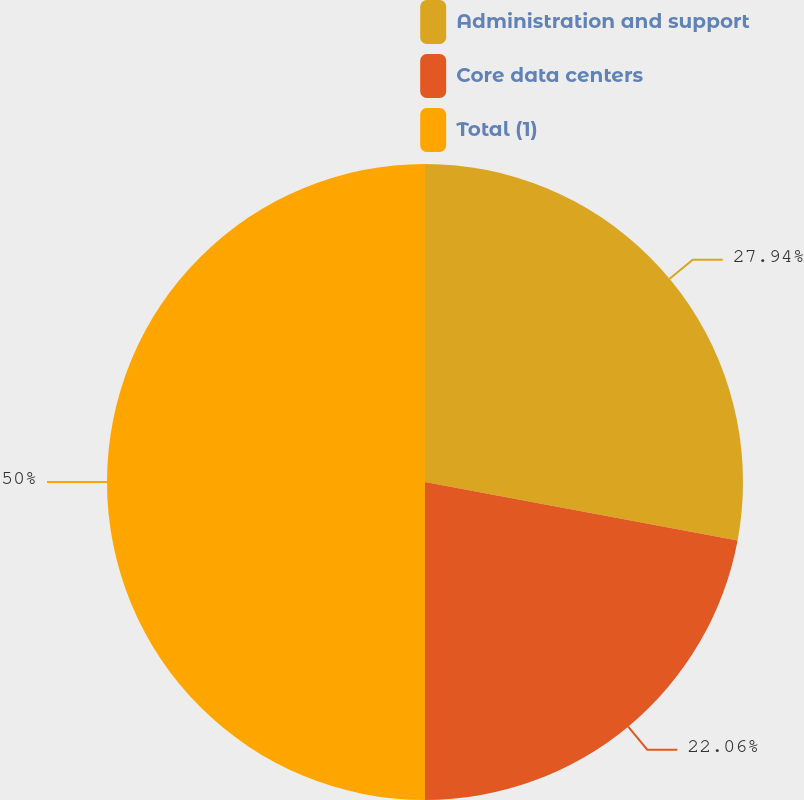Convert chart to OTSL. <chart><loc_0><loc_0><loc_500><loc_500><pie_chart><fcel>Administration and support<fcel>Core data centers<fcel>Total (1)<nl><fcel>27.94%<fcel>22.06%<fcel>50.0%<nl></chart> 